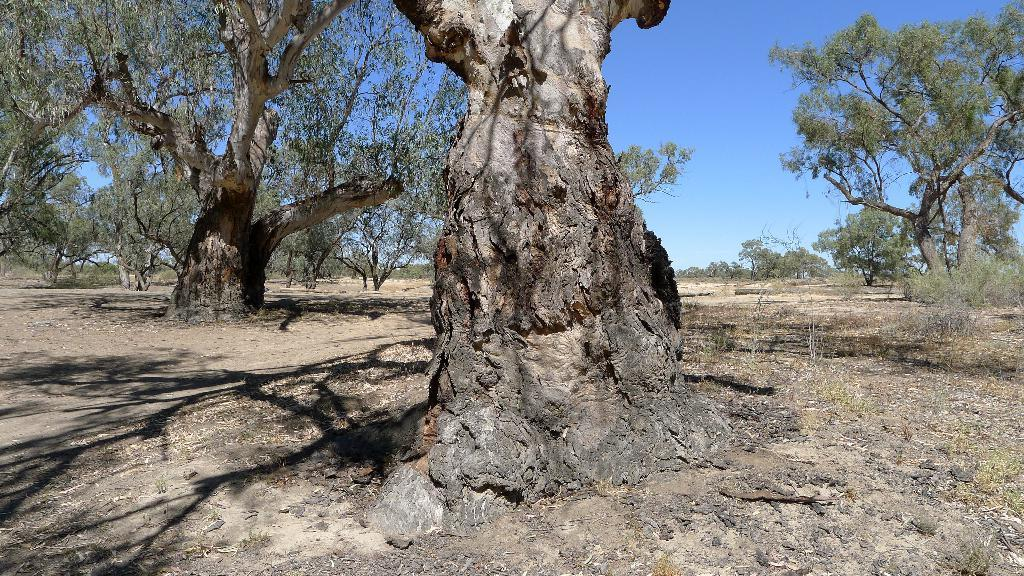What is the main subject of the image? The main subject of the image is a tree trunk. What else can be seen in the image besides the tree trunk? There are trees in the background of the image. What is visible at the top of the image? The sky is visible at the top of the image. How many brothers are sitting under the tree trunk in the image? There are no brothers present in the image; it only features a tree trunk and trees in the background. 